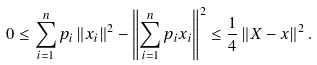Convert formula to latex. <formula><loc_0><loc_0><loc_500><loc_500>0 \leq \sum _ { i = 1 } ^ { n } p _ { i } \left \| x _ { i } \right \| ^ { 2 } - \left \| \sum _ { i = 1 } ^ { n } p _ { i } x _ { i } \right \| ^ { 2 } \leq \frac { 1 } { 4 } \left \| X - x \right \| ^ { 2 } .</formula> 